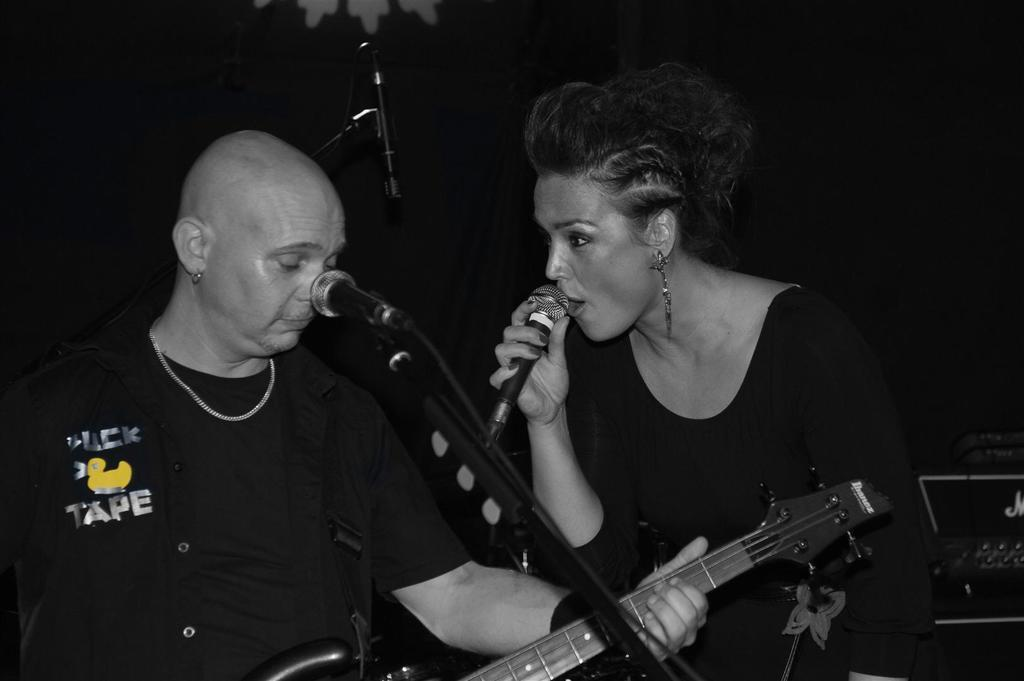What is the woman in the image doing? The woman is holding a microphone and singing. What is the man in the image doing? The man is playing a guitar. What object is the woman holding while singing? The woman is holding a microphone. How many pizzas are being delivered in the image? There are no pizzas or delivery mentioned in the image; it features a woman singing with a microphone and a man playing a guitar. 